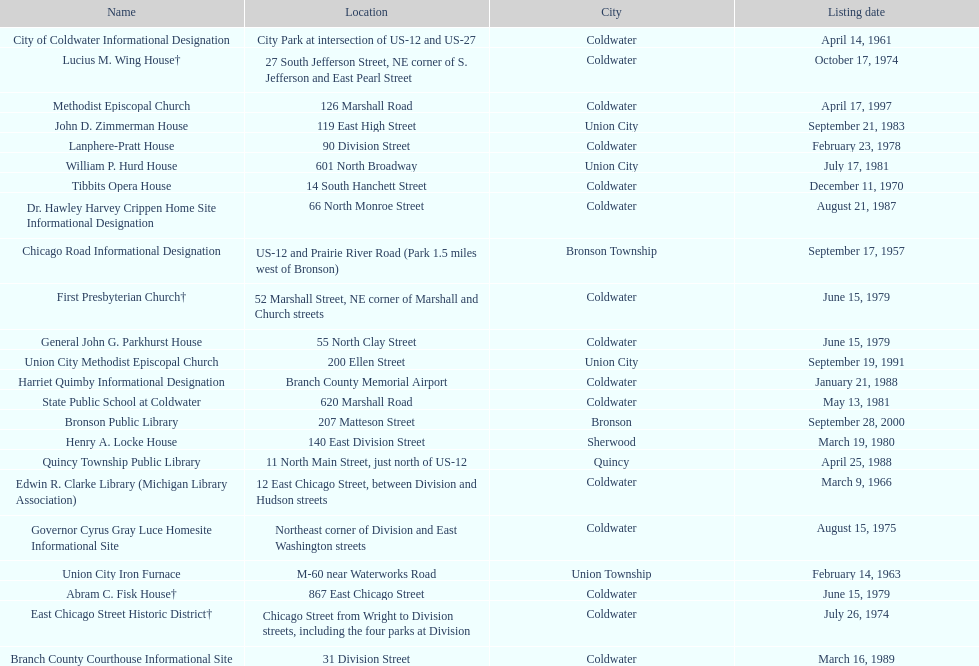Which site was listed earlier, the state public school or the edwin r. clarke library? Edwin R. Clarke Library. 